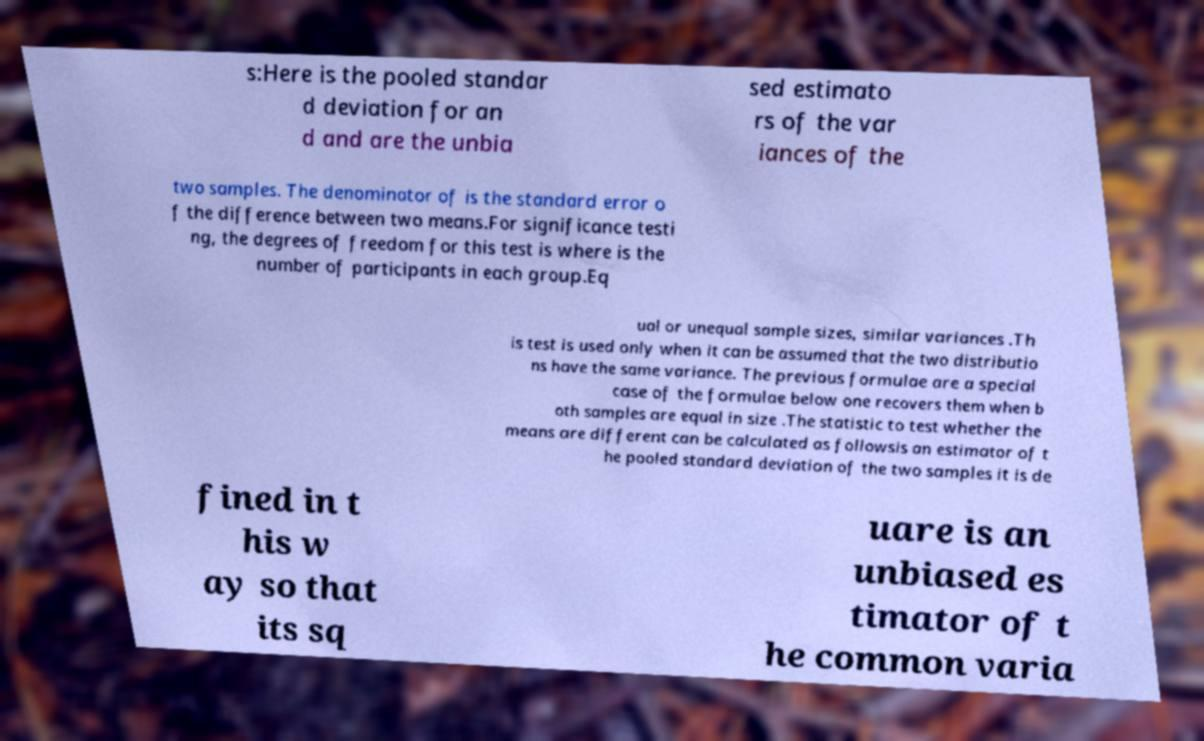Please identify and transcribe the text found in this image. s:Here is the pooled standar d deviation for an d and are the unbia sed estimato rs of the var iances of the two samples. The denominator of is the standard error o f the difference between two means.For significance testi ng, the degrees of freedom for this test is where is the number of participants in each group.Eq ual or unequal sample sizes, similar variances .Th is test is used only when it can be assumed that the two distributio ns have the same variance. The previous formulae are a special case of the formulae below one recovers them when b oth samples are equal in size .The statistic to test whether the means are different can be calculated as followsis an estimator of t he pooled standard deviation of the two samples it is de fined in t his w ay so that its sq uare is an unbiased es timator of t he common varia 